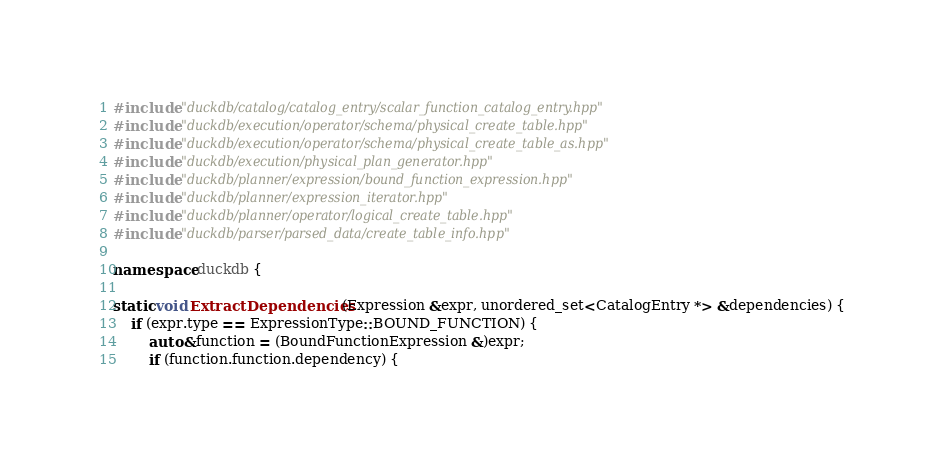<code> <loc_0><loc_0><loc_500><loc_500><_C++_>#include "duckdb/catalog/catalog_entry/scalar_function_catalog_entry.hpp"
#include "duckdb/execution/operator/schema/physical_create_table.hpp"
#include "duckdb/execution/operator/schema/physical_create_table_as.hpp"
#include "duckdb/execution/physical_plan_generator.hpp"
#include "duckdb/planner/expression/bound_function_expression.hpp"
#include "duckdb/planner/expression_iterator.hpp"
#include "duckdb/planner/operator/logical_create_table.hpp"
#include "duckdb/parser/parsed_data/create_table_info.hpp"

namespace duckdb {

static void ExtractDependencies(Expression &expr, unordered_set<CatalogEntry *> &dependencies) {
	if (expr.type == ExpressionType::BOUND_FUNCTION) {
		auto &function = (BoundFunctionExpression &)expr;
		if (function.function.dependency) {</code> 